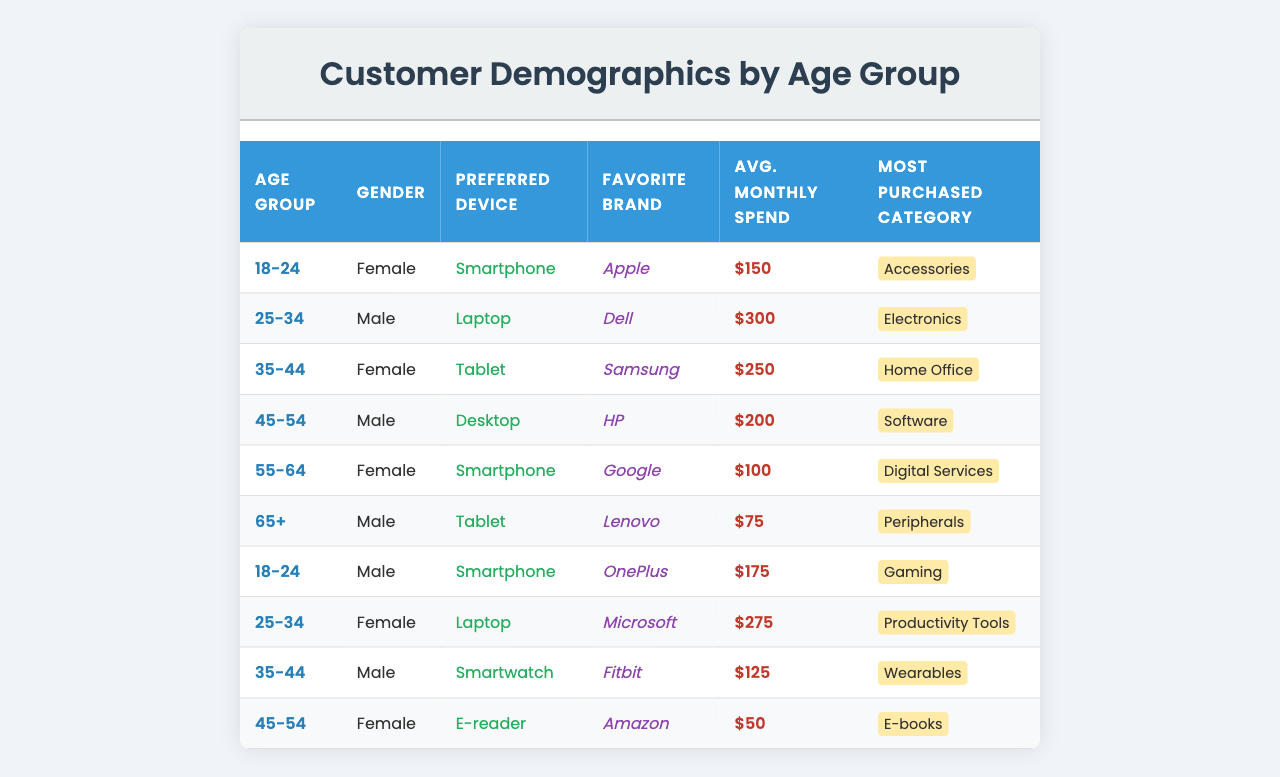What is the average monthly spend for customers aged 25-34? There are two customers in the 25-34 age group with monthly spends of $300 and $275. Adding them gives $300 + $275 = $575, and then dividing by 2 gives an average of $575 / 2 = $287.50.
Answer: 287.50 Which age group has the highest average monthly spend? The age groups and their average monthly spends are as follows: 18-24: $162.50, 25-34: $287.50, 35-44: $187.50, 45-54: $125.00, 55-64: $100.00, 65+: $75.00. The highest average is for 25-34 at $287.50.
Answer: 25-34 Do all customers aged 65 and older prefer tablets? There is one customer in the 65+ age group who prefers a tablet. While this suggests a trend, it's not confirmed that all in this age group prefer tablets, since data can vary.
Answer: No What is the favorite brand of the female customer aged 35-44? The female customer in the 35-44 age group has 'Samsung' listed as her favorite brand according to the table.
Answer: Samsung Which age group spends more on accessories, 18-24 or 25-34? The 18-24 age group has an average spend of $162.50 on accessories, while the 25-34 age group primarily purchases electronics with an average spend of $287.50. Therefore, 18-24 spends more on accessories than the 25-34 group.
Answer: 18-24 How much do males aged 55-64 spend on average? The age group 55-64 has one male customer who spends $75 monthly. Therefore, the average is also $75 since there's only one entry.
Answer: 75 Is there a customer in the age group 45-54 whose preferred device is a smartphone? The table lists two customers aged 45-54 but both prefer either a desktop or an e-reader, indicating there is no smartphone preference in this age group.
Answer: No What is the most purchased category for the female customer aged 45-54? The female customer aged 45-54 has 'E-books' noted as her most purchased category.
Answer: E-books How does the average monthly spend of males aged 18-24 compare to females of the same age group? For males in the 18-24 age group, the average spend is $175, and for females it is $150. Therefore, males spend more than females by $175 - $150 = $25.
Answer: Males spend $25 more Which preferred device is most common among customers aged 18-24? Analyzing the data, both male and female customers aged 18-24 prefer smartphones, making it the most common device within this age group.
Answer: Smartphone What percentage of customers in the table prefer laptops? There are two customers who prefer laptops out of a total of ten. Therefore, the percentage is (2 / 10) * 100 = 20%.
Answer: 20% 